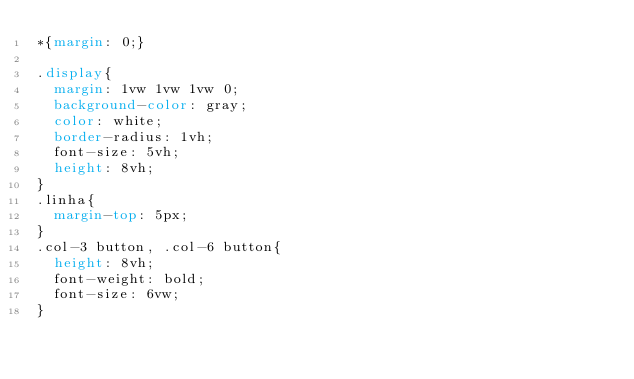<code> <loc_0><loc_0><loc_500><loc_500><_CSS_>*{margin: 0;}

.display{
  margin: 1vw 1vw 1vw 0;
  background-color: gray;
  color: white;
  border-radius: 1vh;
  font-size: 5vh;
  height: 8vh;
}
.linha{
  margin-top: 5px;
}
.col-3 button, .col-6 button{
  height: 8vh;
  font-weight: bold;
  font-size: 6vw;
}</code> 